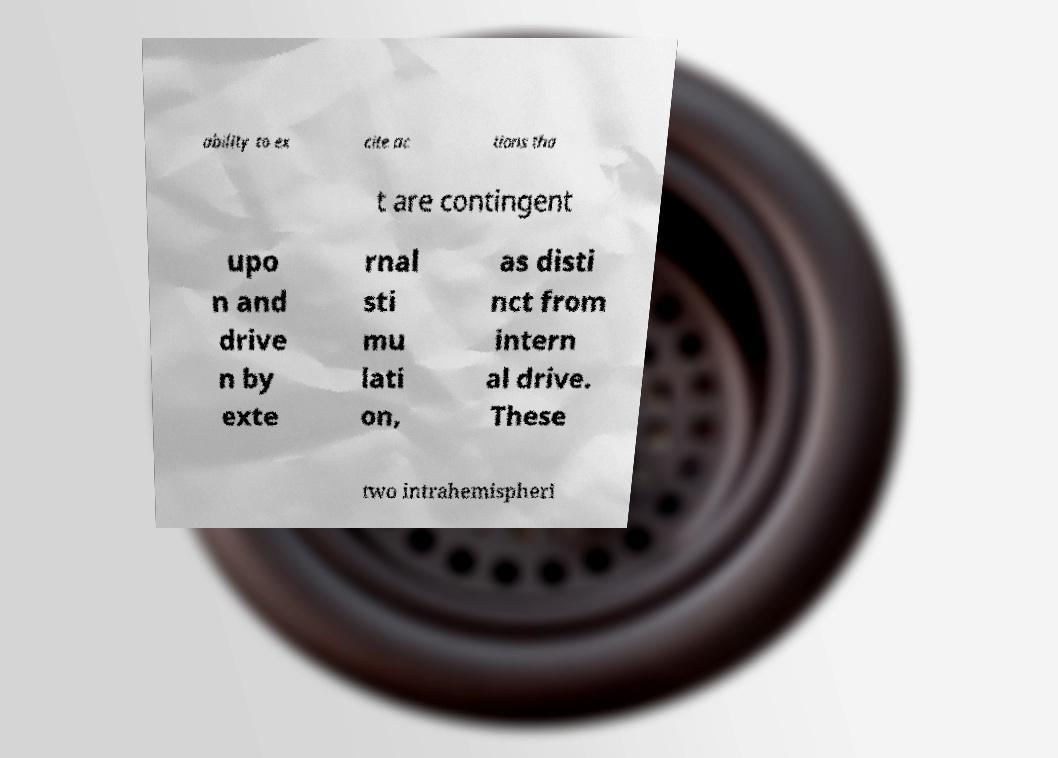I need the written content from this picture converted into text. Can you do that? ability to ex cite ac tions tha t are contingent upo n and drive n by exte rnal sti mu lati on, as disti nct from intern al drive. These two intrahemispheri 